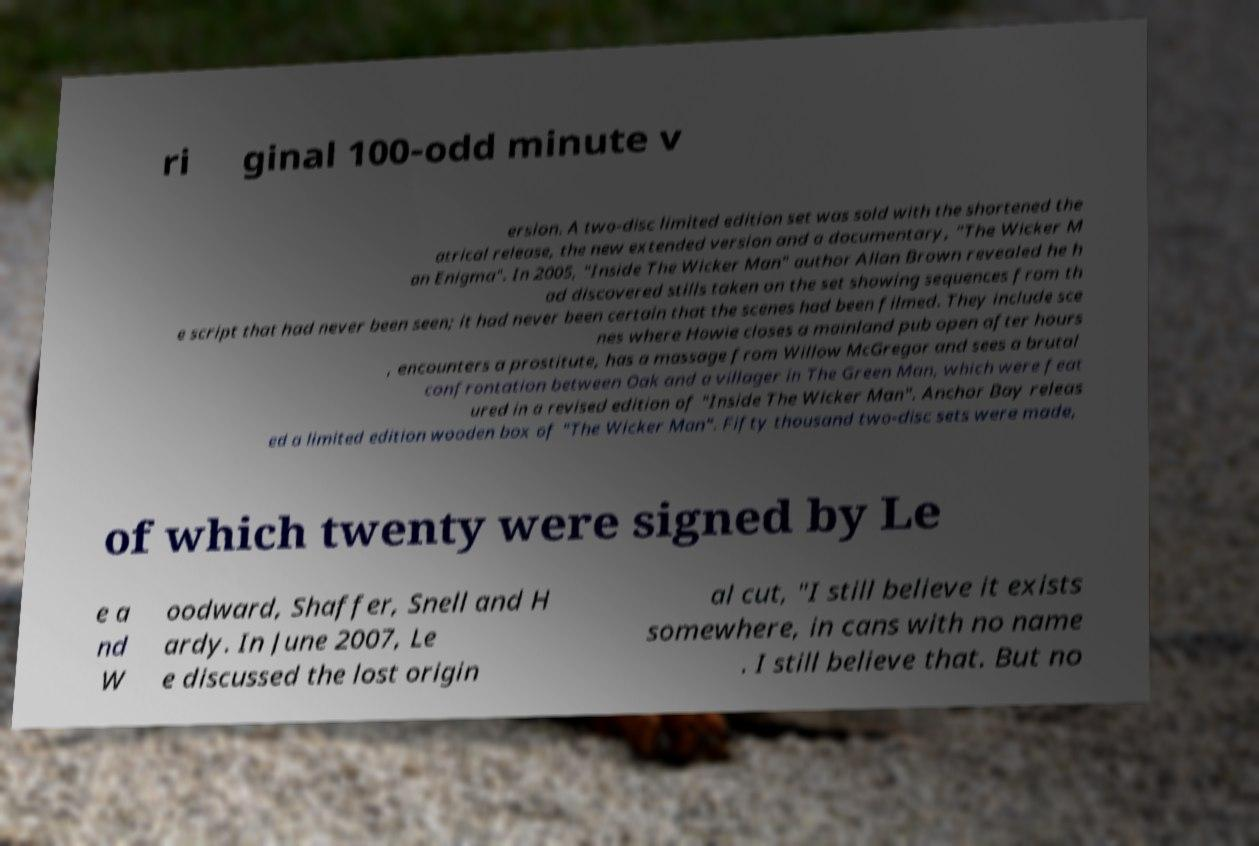There's text embedded in this image that I need extracted. Can you transcribe it verbatim? ri ginal 100-odd minute v ersion. A two-disc limited edition set was sold with the shortened the atrical release, the new extended version and a documentary, "The Wicker M an Enigma". In 2005, "Inside The Wicker Man" author Allan Brown revealed he h ad discovered stills taken on the set showing sequences from th e script that had never been seen; it had never been certain that the scenes had been filmed. They include sce nes where Howie closes a mainland pub open after hours , encounters a prostitute, has a massage from Willow McGregor and sees a brutal confrontation between Oak and a villager in The Green Man, which were feat ured in a revised edition of "Inside The Wicker Man". Anchor Bay releas ed a limited edition wooden box of "The Wicker Man". Fifty thousand two-disc sets were made, of which twenty were signed by Le e a nd W oodward, Shaffer, Snell and H ardy. In June 2007, Le e discussed the lost origin al cut, "I still believe it exists somewhere, in cans with no name . I still believe that. But no 